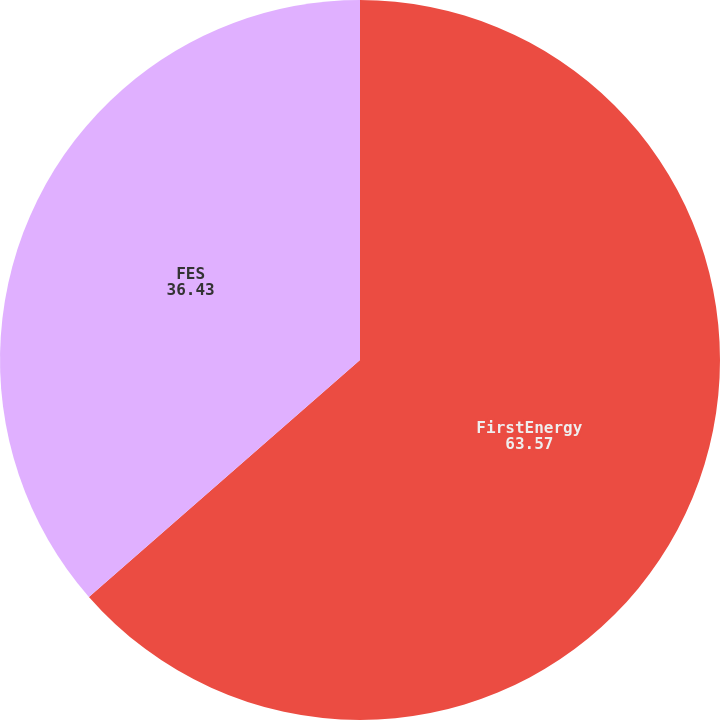Convert chart to OTSL. <chart><loc_0><loc_0><loc_500><loc_500><pie_chart><fcel>FirstEnergy<fcel>FES<nl><fcel>63.57%<fcel>36.43%<nl></chart> 